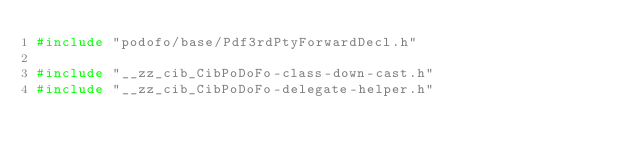<code> <loc_0><loc_0><loc_500><loc_500><_C++_>#include "podofo/base/Pdf3rdPtyForwardDecl.h"

#include "__zz_cib_CibPoDoFo-class-down-cast.h"
#include "__zz_cib_CibPoDoFo-delegate-helper.h"</code> 